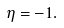Convert formula to latex. <formula><loc_0><loc_0><loc_500><loc_500>\eta = - 1 .</formula> 